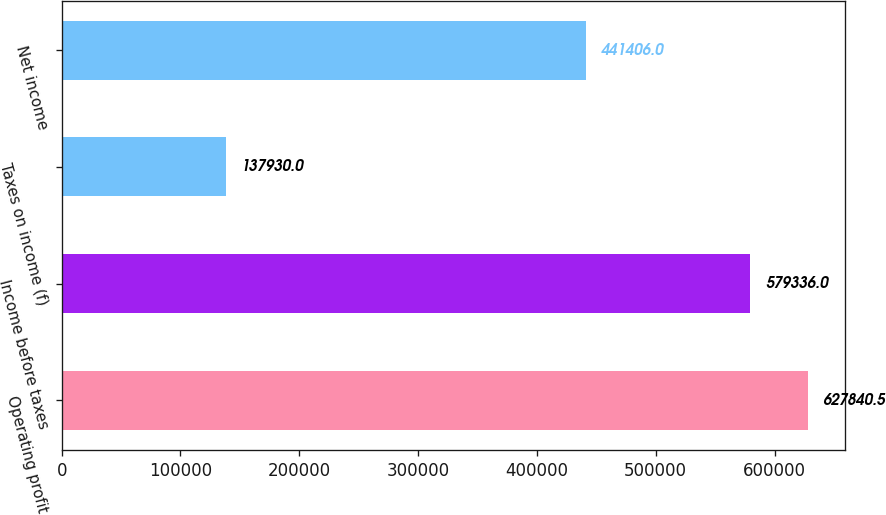<chart> <loc_0><loc_0><loc_500><loc_500><bar_chart><fcel>Operating profit<fcel>Income before taxes<fcel>Taxes on income (f)<fcel>Net income<nl><fcel>627840<fcel>579336<fcel>137930<fcel>441406<nl></chart> 